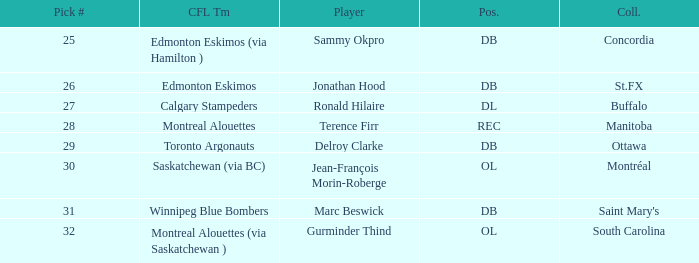Which College has a Position of ol, and a Pick # smaller than 32? Montréal. 